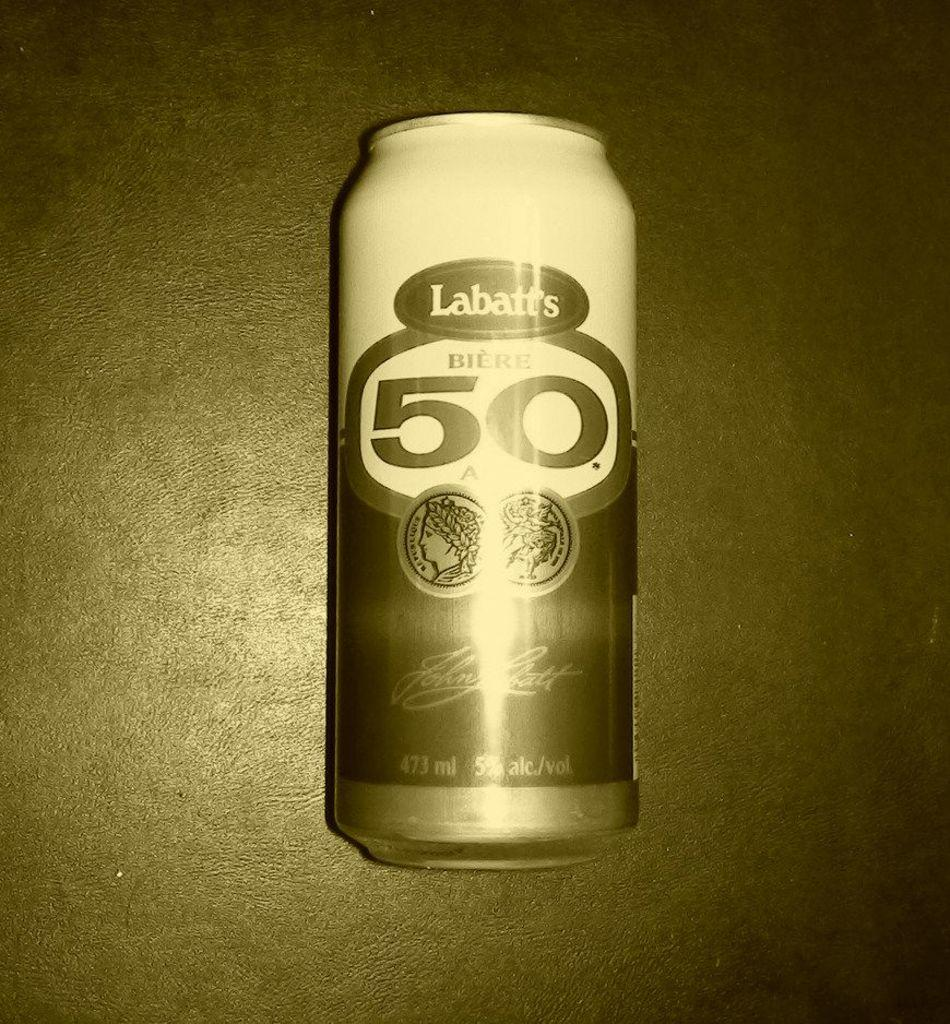<image>
Describe the image concisely. A single can of Labatt's lies down on the table. 